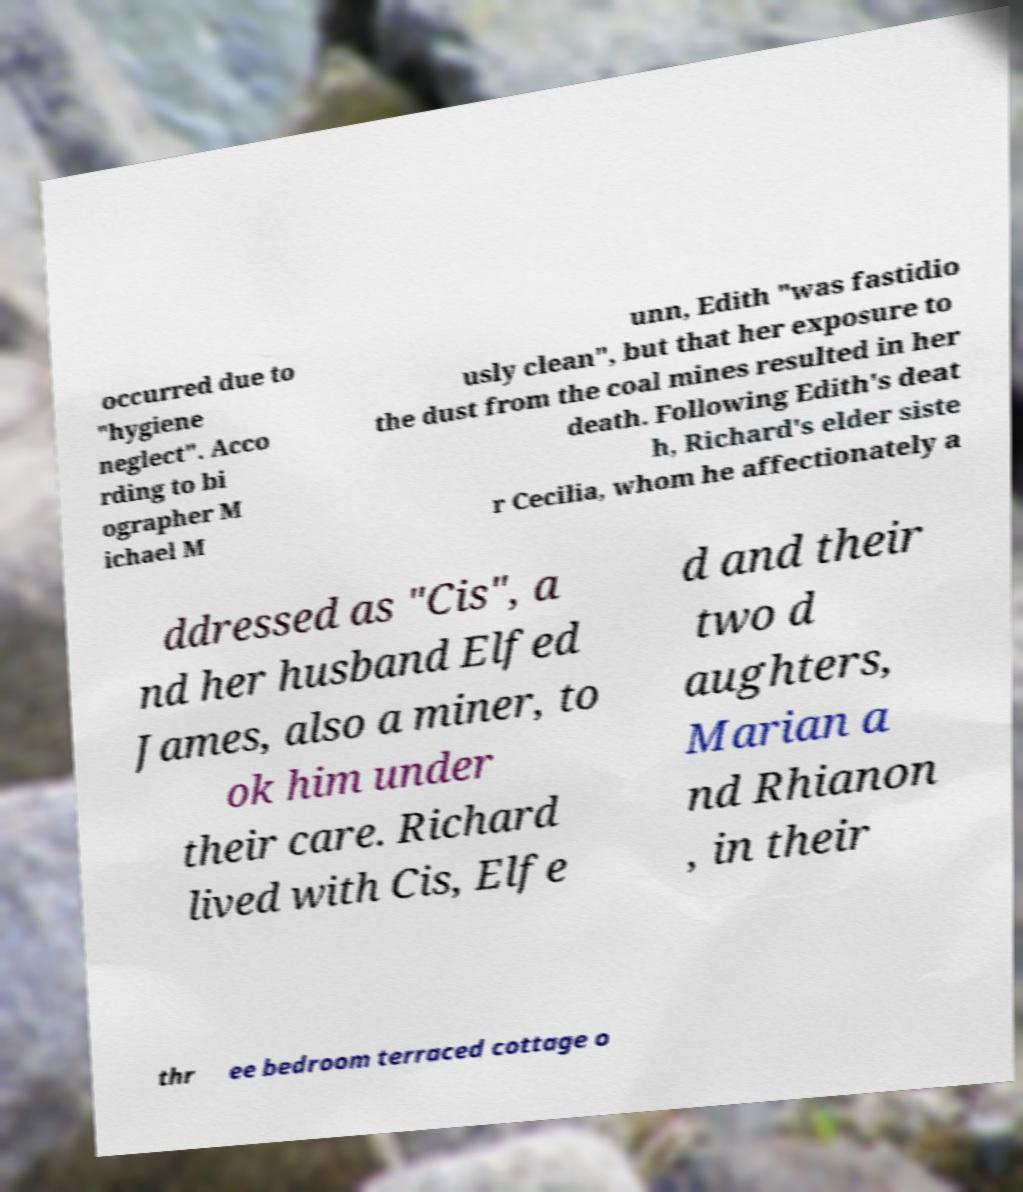I need the written content from this picture converted into text. Can you do that? occurred due to "hygiene neglect". Acco rding to bi ographer M ichael M unn, Edith "was fastidio usly clean", but that her exposure to the dust from the coal mines resulted in her death. Following Edith's deat h, Richard's elder siste r Cecilia, whom he affectionately a ddressed as "Cis", a nd her husband Elfed James, also a miner, to ok him under their care. Richard lived with Cis, Elfe d and their two d aughters, Marian a nd Rhianon , in their thr ee bedroom terraced cottage o 